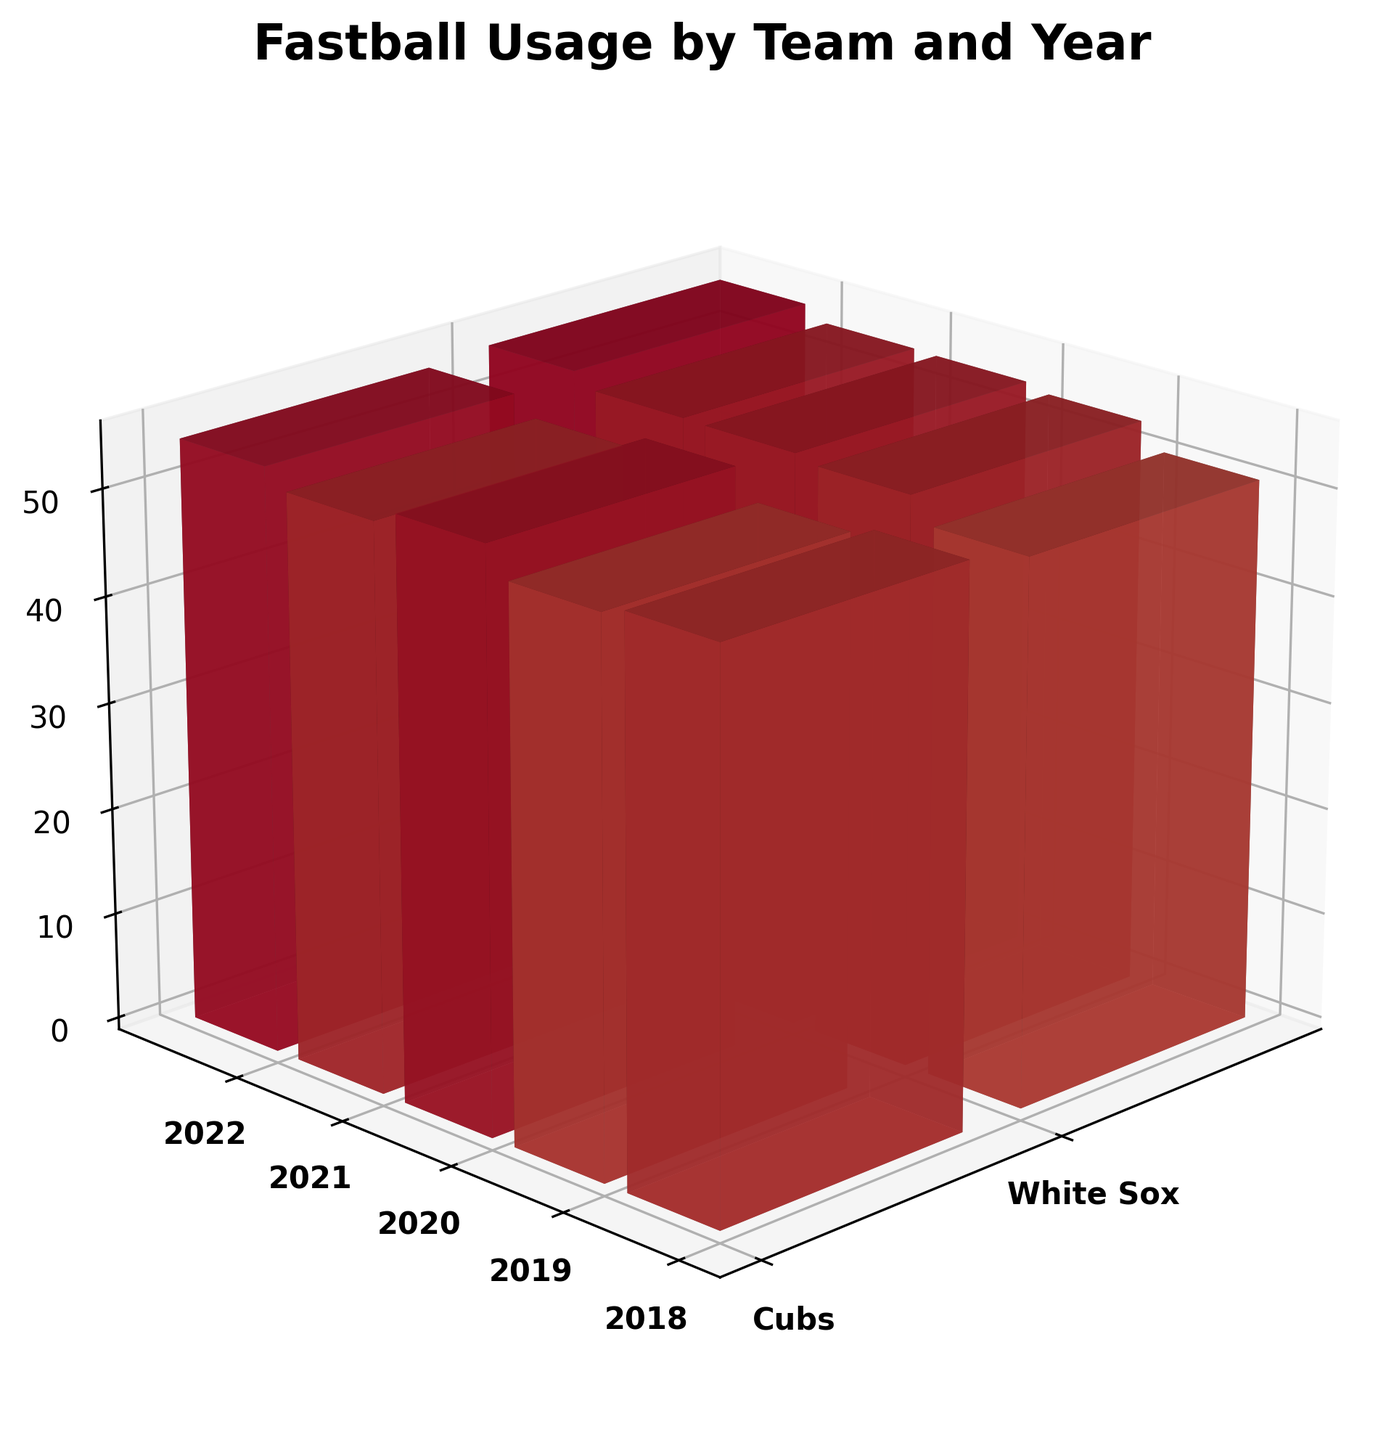what is the title of the figure? The title of the figure is often found at the top and provides a summary of the visualized data. Here, it reads 'Fastball Usage by Team and Year', indicating the focus is on fastball percentage over different years for different teams.
Answer: Fastball Usage by Team and Year Which team shows a higher fastball usage in 2022? To determine the team with the higher fastball usage in 2022, compare the heights of the bars for the White Sox and Cubs in the 2022 segment. The White Sox bar is taller.
Answer: White Sox How did the Cubs' fastball usage change from 2018 to 2022? Look at the height of the bars for the Cubs in 2018 and then in 2022. The bar height increases, indicating an increase in fastball usage.
Answer: Increased Which year shows the lowest fastball usage for the White Sox? Examine the heights of the bars corresponding to the White Sox for each year. The shortest bar represents the lowest usage.
Answer: 2018 What's the average fastball usage for the Cubs over the 5 years? Add the fastball usage percentages for each year (52.3 + 50.8 + 51.5 + 53.1 + 54.2) and divide by 5 to get the average.
Answer: 52.38% Between Cubs and Sox, which team showed a more significant increase in fastball usage from 2018 to 2022? Calculate the difference in fastball usage from 2018 to 2022 for both teams, compare the differences: Cubs increased by 1.9%, White Sox increased by 1.4%.
Answer: Cubs In which year did both teams have almost similar fastball usage? Compare the heights of the bars for both teams across all years. 2020 shows similar bar heights for both teams.
Answer: 2020 How does the 3D perspective affect the visibility of yearly fastball usage differences? The 3D perspective might make it harder to accurately gauge differences in bar heights, especially for years closer in percentage. Details often require careful observation from different angles.
Answer: Makes it harder Does the figure indicate any trend in fastball usage among the teams over the years? Visually, both teams show an increasing trend in the height of bars, indicating increased fastball usage over the years.
Answer: Increasing Trend 